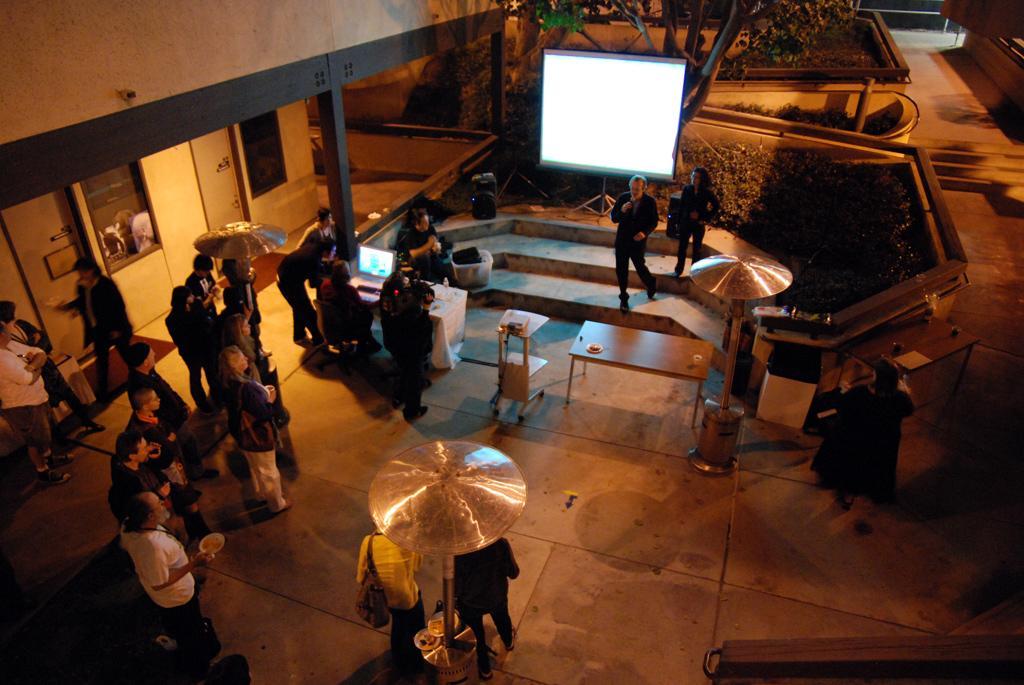Describe this image in one or two sentences. In this picture there are a group of people standing and there is the projector screen hire. 